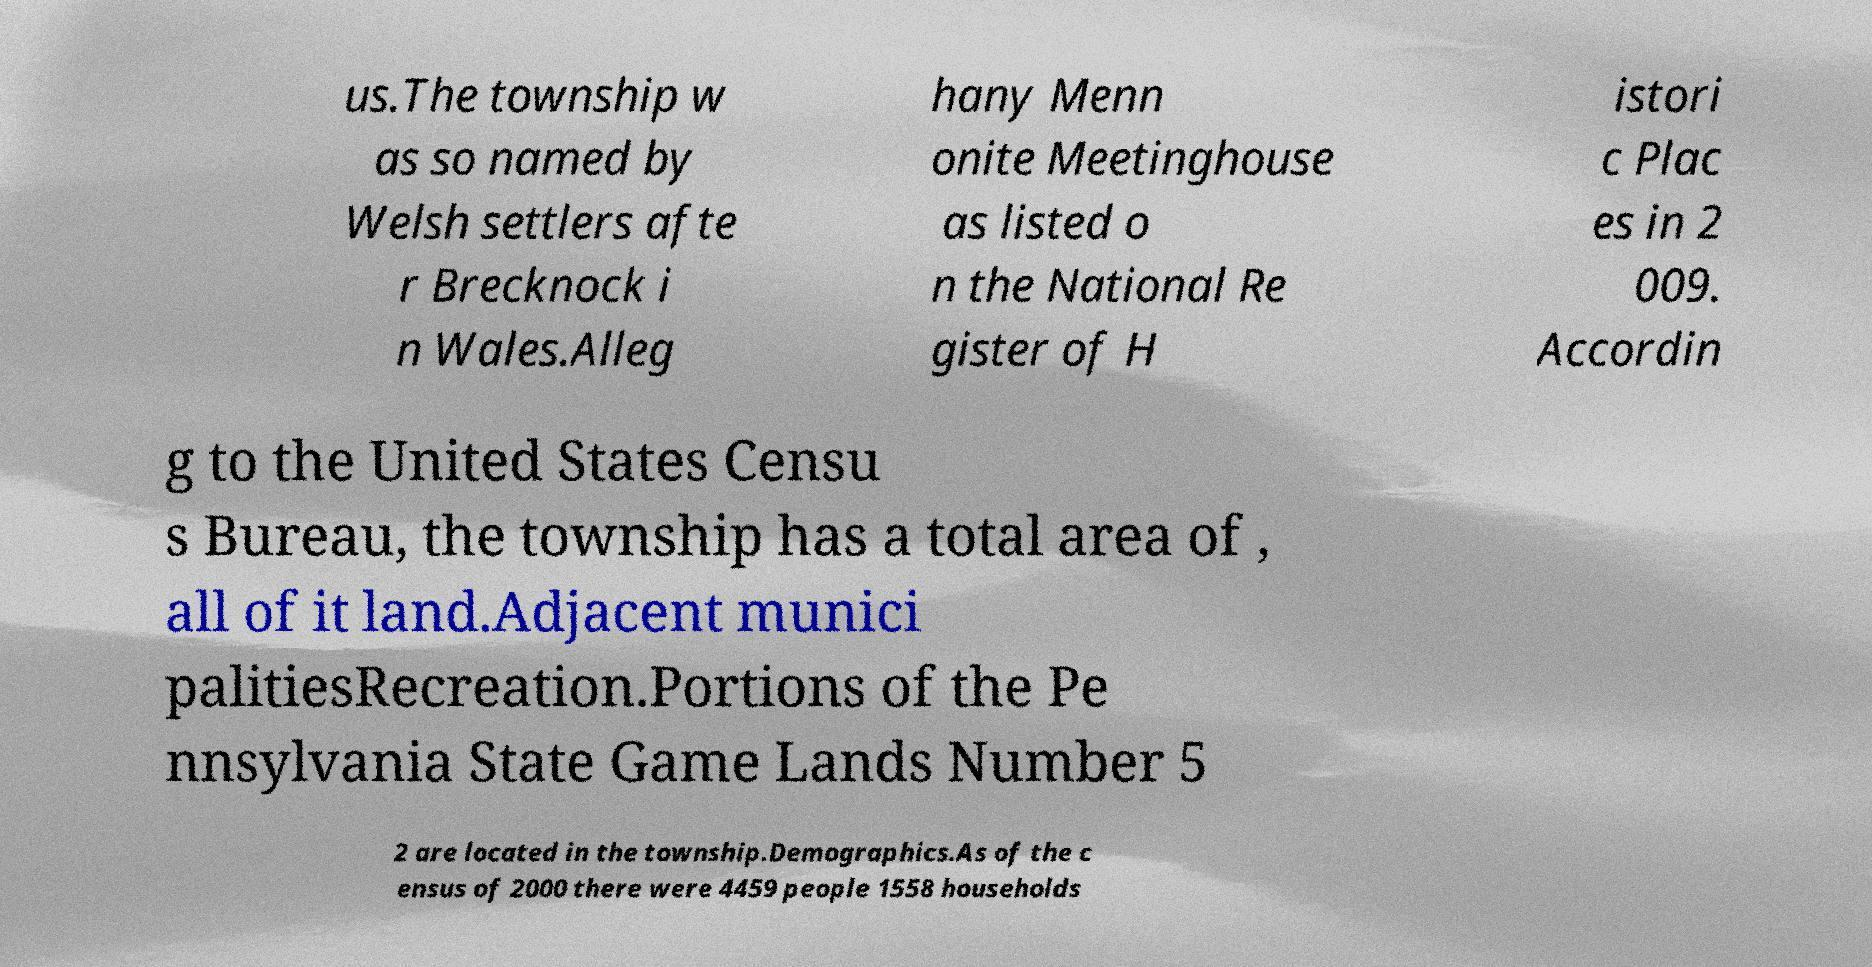There's text embedded in this image that I need extracted. Can you transcribe it verbatim? us.The township w as so named by Welsh settlers afte r Brecknock i n Wales.Alleg hany Menn onite Meetinghouse as listed o n the National Re gister of H istori c Plac es in 2 009. Accordin g to the United States Censu s Bureau, the township has a total area of , all of it land.Adjacent munici palitiesRecreation.Portions of the Pe nnsylvania State Game Lands Number 5 2 are located in the township.Demographics.As of the c ensus of 2000 there were 4459 people 1558 households 